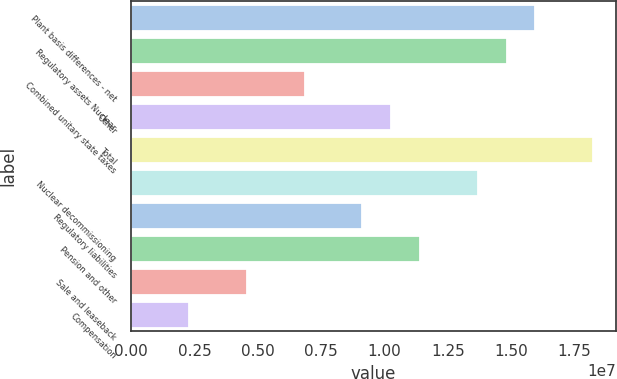Convert chart. <chart><loc_0><loc_0><loc_500><loc_500><bar_chart><fcel>Plant basis differences - net<fcel>Regulatory assets Nuclear<fcel>Combined unitary state taxes<fcel>Other<fcel>Total<fcel>Nuclear decommissioning<fcel>Regulatory liabilities<fcel>Pension and other<fcel>Sale and leaseback<fcel>Compensation<nl><fcel>1.59517e+07<fcel>1.48131e+07<fcel>6.84338e+06<fcel>1.0259e+07<fcel>1.82288e+07<fcel>1.36746e+07<fcel>9.12045e+06<fcel>1.13975e+07<fcel>4.5663e+06<fcel>2.28922e+06<nl></chart> 